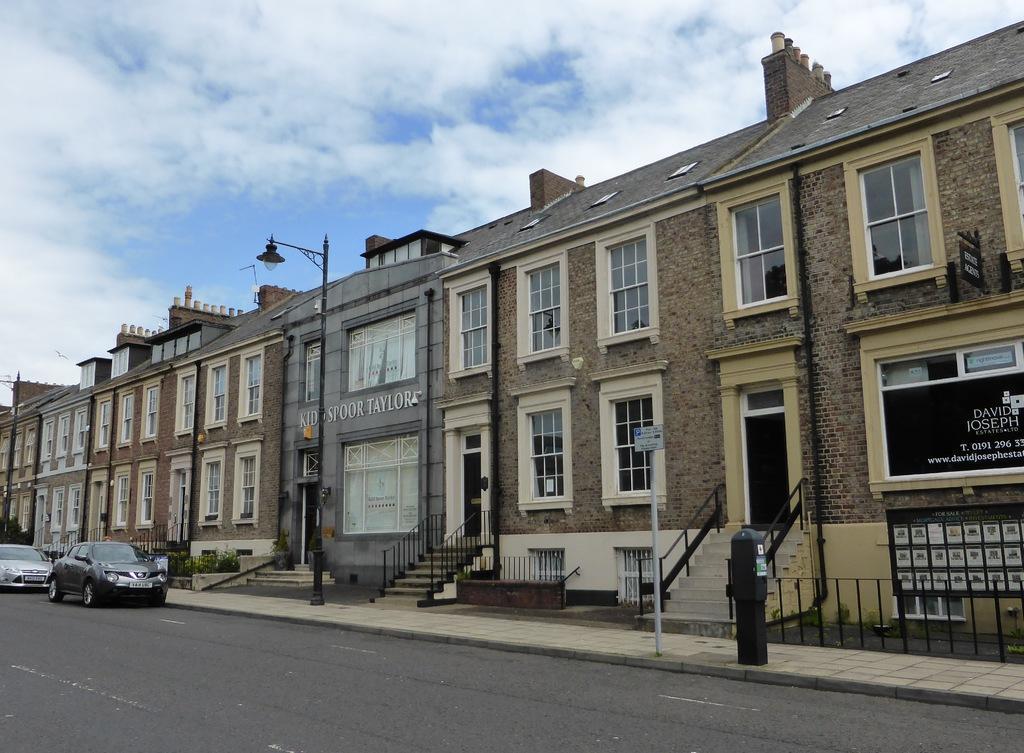How would you summarize this image in a sentence or two? This image is taken outdoors. At the top of the image there is a sky with clouds. At the bottom of the image there is a road. On the left side of the image two cars are parked on the road. In the middle of the image there are a few buildings with walls, windows, doors and roofs. There are a few plants and railings. There is a street light and on the right side of the image there is a board with a text on it. 